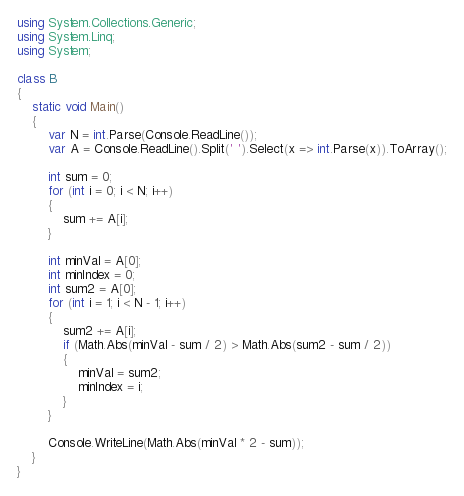<code> <loc_0><loc_0><loc_500><loc_500><_C#_>
using System.Collections.Generic;
using System.Linq;
using System;

class B
{
    static void Main()
    {
        var N = int.Parse(Console.ReadLine());
        var A = Console.ReadLine().Split(' ').Select(x => int.Parse(x)).ToArray();

        int sum = 0;
        for (int i = 0; i < N; i++)
        {
            sum += A[i];
        }
        
        int minVal = A[0];
        int minIndex = 0;
        int sum2 = A[0];
        for (int i = 1; i < N - 1; i++)
        {
            sum2 += A[i];
            if (Math.Abs(minVal - sum / 2) > Math.Abs(sum2 - sum / 2))
            {
                minVal = sum2;
                minIndex = i;
            }
        }

        Console.WriteLine(Math.Abs(minVal * 2 - sum));
    }
}
</code> 